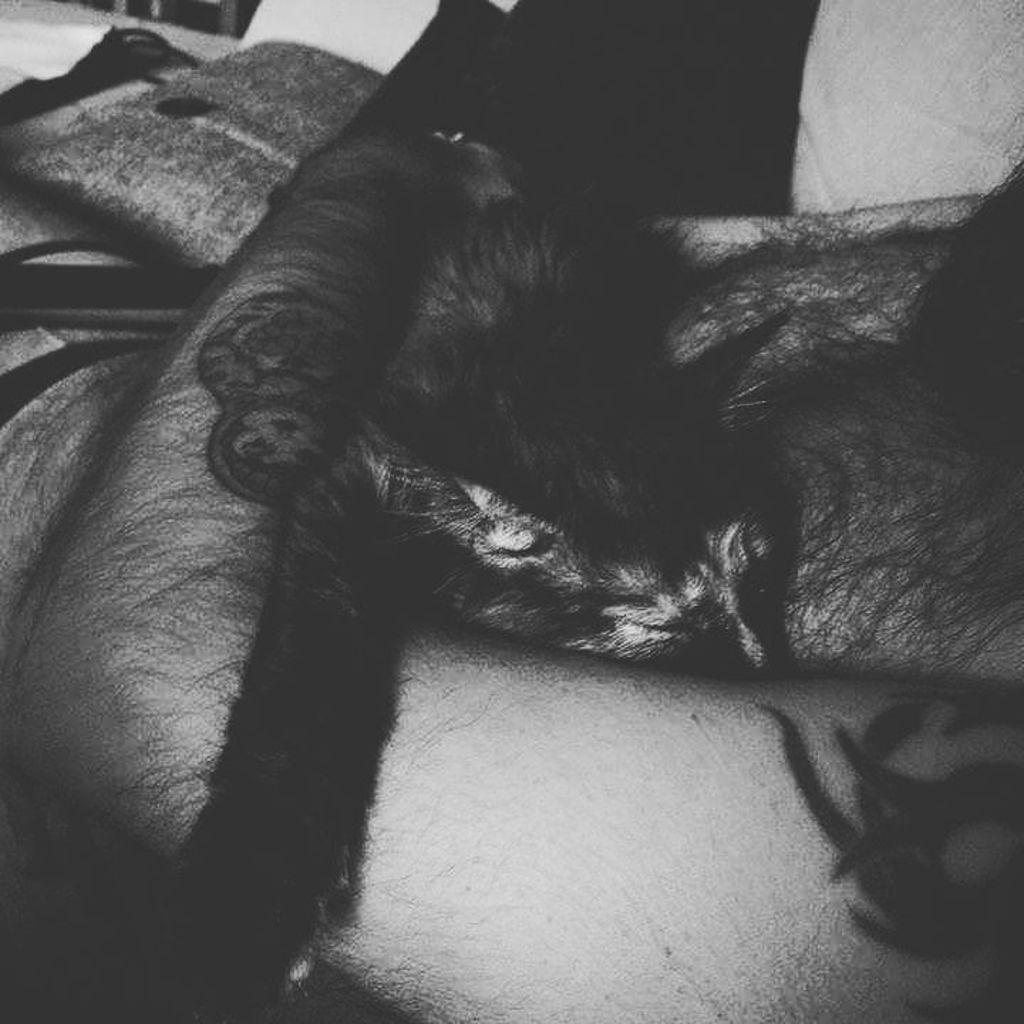In one or two sentences, can you explain what this image depicts? In this image I can see a person is holding a cat. The image is in black and white. 